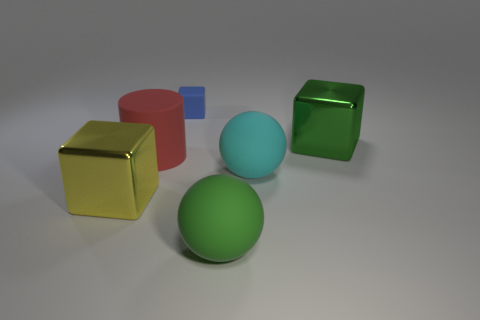What do the colors of the objects tell us about the scene? The colors of the objects—gold, red, cyan, green, and blue—do not convey a particular theme, but they provide a visually pleasing contrast and might be used to study color theory or the effects of different hues in a controlled, neutral setting. 